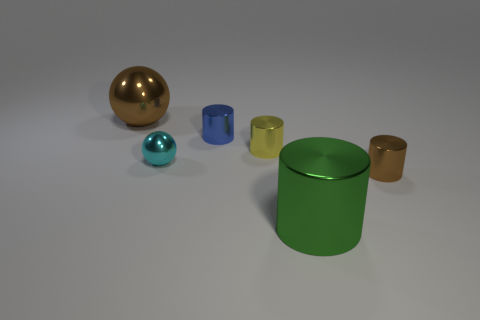Subtract all large shiny cylinders. How many cylinders are left? 3 Subtract all cyan balls. How many balls are left? 1 Subtract all cylinders. How many objects are left? 2 Add 1 small cylinders. How many objects exist? 7 Subtract all small blue things. Subtract all small red matte spheres. How many objects are left? 5 Add 1 large metal cylinders. How many large metal cylinders are left? 2 Add 6 brown things. How many brown things exist? 8 Subtract 0 brown blocks. How many objects are left? 6 Subtract 1 spheres. How many spheres are left? 1 Subtract all gray spheres. Subtract all gray cylinders. How many spheres are left? 2 